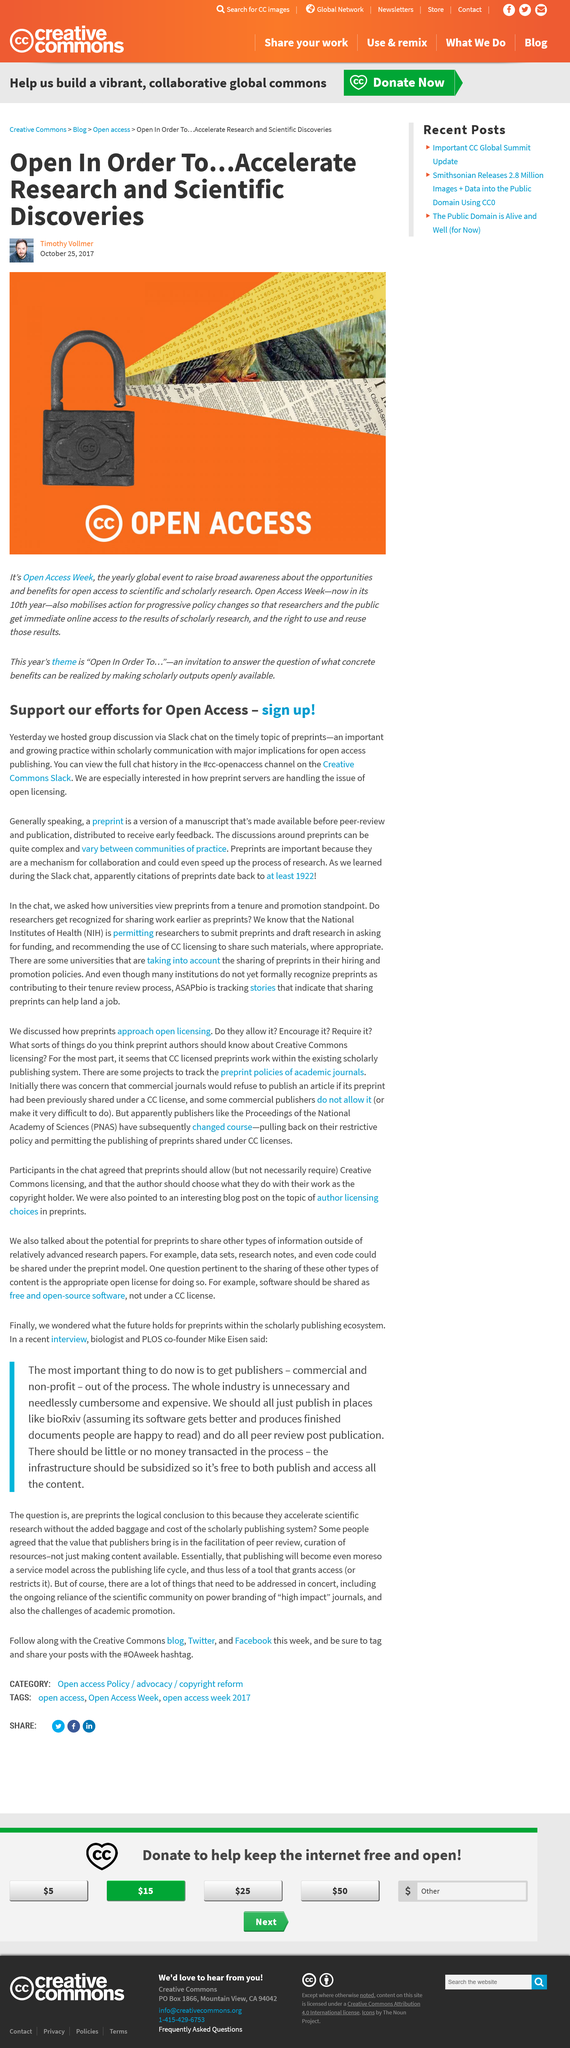Indicate a few pertinent items in this graphic. Open Access Week is an annual event that aims to increase awareness and understanding of open access to scientific and scholarly research, highlighting the opportunities and benefits it provides. The topic that was discussed in a group discussion via Slack chat was preprints, which refers to a version of a manuscript that is released for review before it is published. Preprints are crucial in this field as they facilitate collaboration by providing early access to research for inspection and feedback, enabling authors to make necessary adjustments for improvement. The group hosted the discussion on preprints via Slack chat at an unknown location. The author of this article is Timothy Vollmer. 